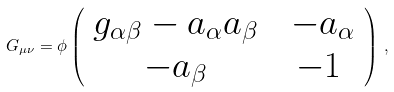Convert formula to latex. <formula><loc_0><loc_0><loc_500><loc_500>G _ { \mu \nu } = \phi \left ( \begin{array} { c c c } g _ { \alpha \beta } - a _ { \alpha } a _ { \beta } & & - a _ { \alpha } \\ - a _ { \beta } & & - 1 \ \end{array} \right ) \, ,</formula> 